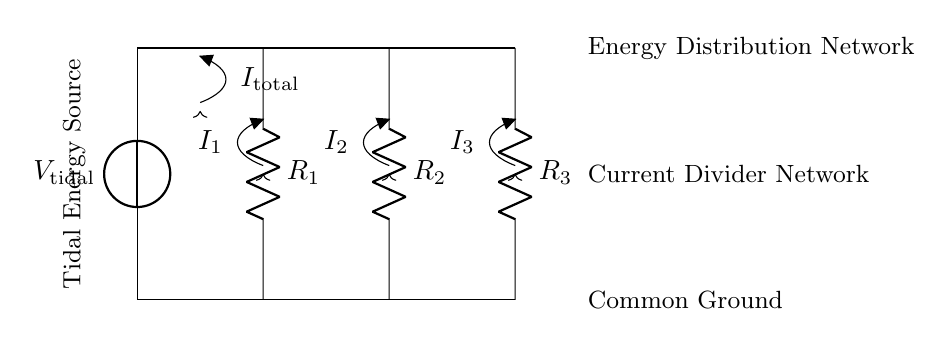What is the source of energy in this circuit? The energy source is labeled as V tidal, indicating it derives energy from tidal resources.
Answer: Tidal energy source What are the resistors labeled in this circuit? The resistors are labeled as R1, R2, and R3, each representing a different path for current distribution.
Answer: R1, R2, R3 What is the total current entering the circuit? The total current entering is represented as I total, which indicates the initial current supplied by the tidal source.
Answer: I total How many branches are there in the current divider network? The current divider displays three resistive branches (R1, R2, R3), through which the total current splits.
Answer: Three Which resistor is closest to the voltage source? R1 is the resistor closest to the voltage source at the top of the circuit diagram.
Answer: R1 If R1 is half the resistance of R2 and R3, what current flows through R1? In a current divider, if R1 has less resistance than R2 and R3, it will receive a greater share of the current; however, specific values are needed for calculation.
Answer: Greater share What happens to the total current as it passes through the resistors? As the total current passes through the resistors, it divides among R1, R2, and R3 according to their resistances, demonstrating the current division principle.
Answer: Divides 